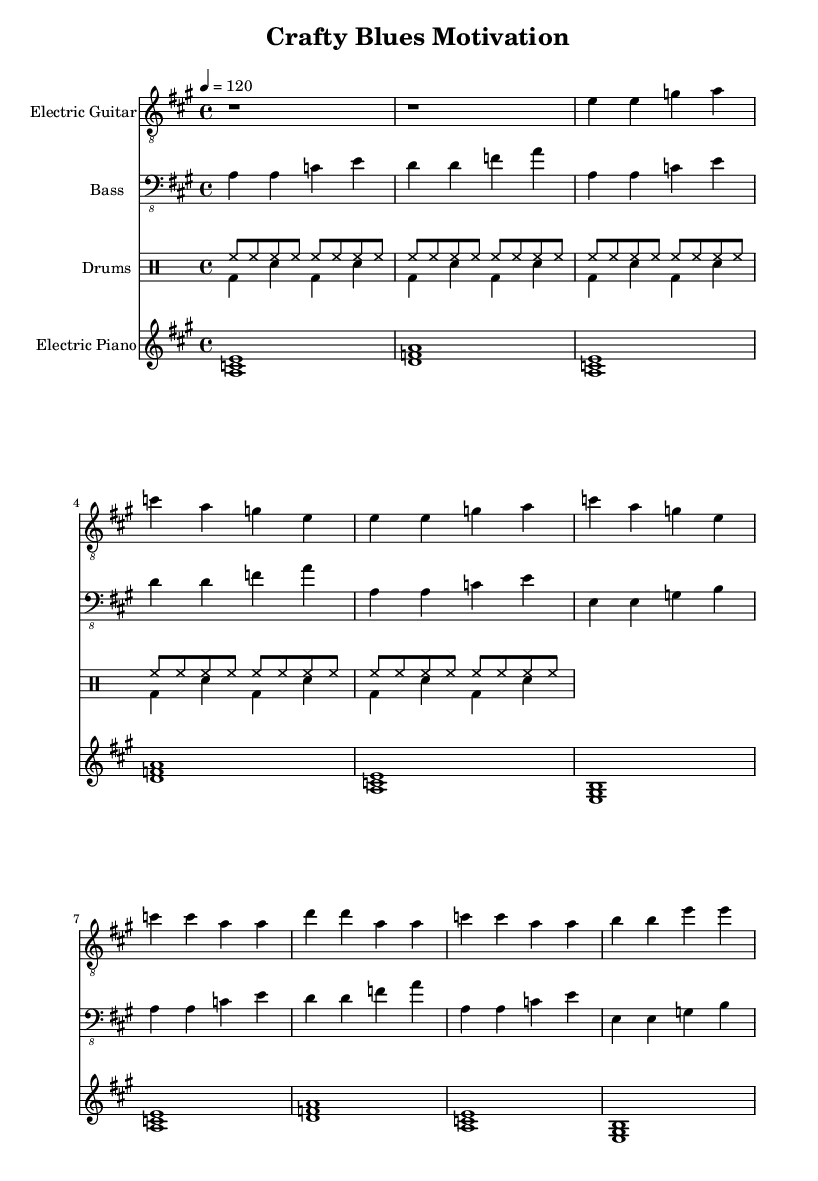What is the key signature of this music? The key signature shows two sharps, which indicates that the music is in A major. The presence of sharps can be seen at the beginning of the staff, corresponding to F# and C#.
Answer: A major What is the time signature of this piece? The time signature is indicated at the beginning of the staff as 4/4, meaning there are four beats in each measure, and the quarter note gets one beat. This can be identified by the numbers that are presented together, where the top number tells how many beats per measure.
Answer: 4/4 What is the tempo marking of this music? The tempo is marked as 120 beats per minute, shown with the indication "4 = 120". This indicates that there are 120 quarter note beats in one minute. The number next to the quarter note defines the speed of the piece.
Answer: 120 How many measures are there in the verse section? In the verse section, there are four measures present as seen upon reviewing the rhythmic structure indicated in the electric guitar and bass staff lines. Each section is separated clearly by the bar lines.
Answer: 4 What instruments are included in this composition? The composition includes the electric guitar, bass, drums, and electric piano as it is stated in the staff labels. Each instrument is notated on its own staff, indicating the parts played by each.
Answer: Electric Guitar, Bass, Drums, Electric Piano Which chord is primarily used in the chorus? The primary chord used in the chorus is C major, as seen in the chord mapping on the staff lines in the section marked as the chorus. This can be deduced from the recurring C note in the bass and the corresponding notes in the melody.
Answer: C major 